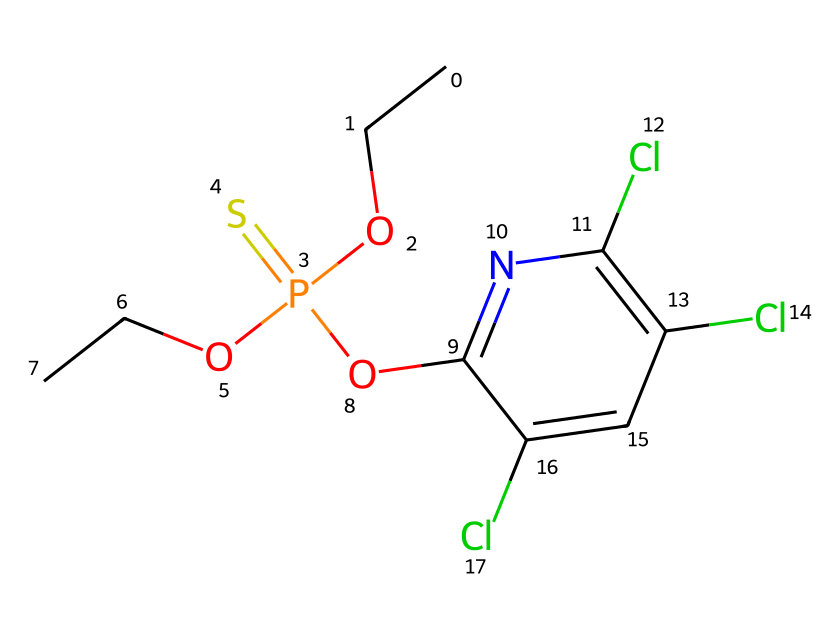How many phosphorus atoms are present in the structure? The chemical structure contains one phosphorus atom, which is identified at the central position in the phosphorothioate functional group.
Answer: one What is the functional group present in this compound? The compound contains an organophosphate functional group, characterized by the presence of phosphorus bound to oxygen and deriving from phosphate chemistry.
Answer: organophosphate How many chlorine atoms are in the structure? There are three chlorine atoms visible as substituents on the aromatic ring, indicated by the 'Cl' symbols in the SMILES representation.
Answer: three What type of pesticide is represented by this structure? This structure represents an organophosphate pesticide, commonly used for livestock pest control due to its efficacy against insects.
Answer: organophosphate What is the molecular formula based on the SMILES provided? To derive the molecular formula, we count the atoms of each element: C (9), H (10), Cl (3), N (1), O (4), P (1), S (1), which gives the molecular formula C9H10Cl3N1O4P1S1.
Answer: C9H10Cl3N1O4P1S1 What additional element is present in this molecule besides phosphorus? In addition to phosphorus, sulfur is also present in the structure, indicated by the 'S' in the SMILES notation.
Answer: sulfur Which atom in the structure contributes to its potential toxicity? The phosphorus atom contributes to the toxicity of this organophosphate pesticide, as it is known for its ability to inhibit essential enzymes in pests through binding.
Answer: phosphorus 